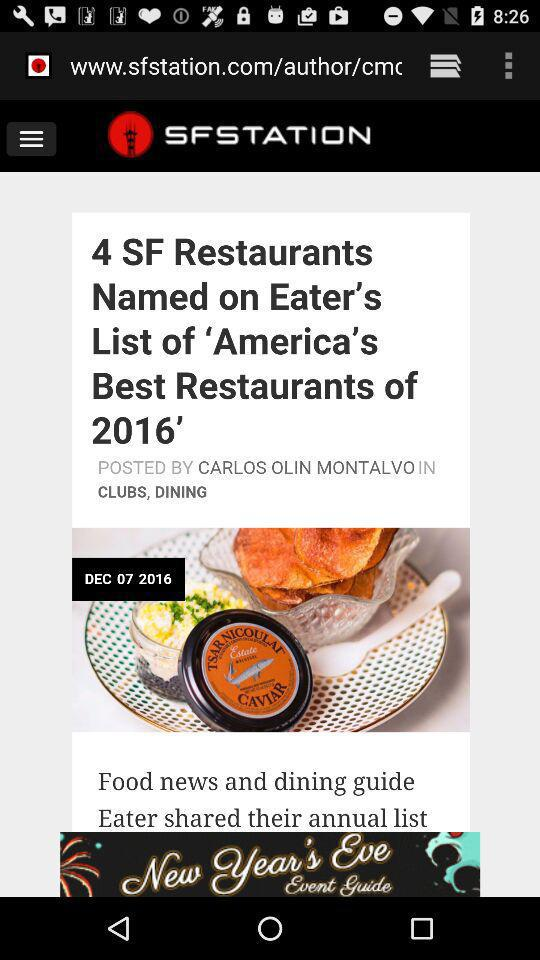What is the date? The date is December 7, 2016. 